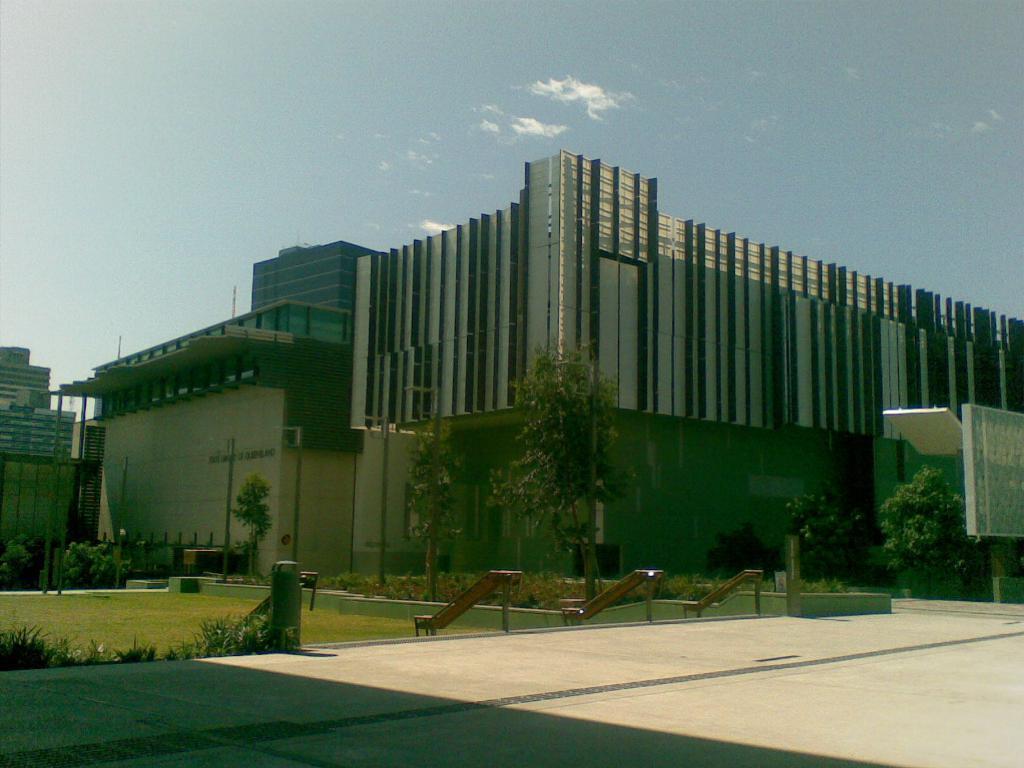Describe this image in one or two sentences. At the bottom of the image there is floor. Behind the floor there is a garden with grass and small plants on the ground. And also there are slides. Behind them there are trees and also there are buildings with walls and glasses. At the top of the image there is sky. 